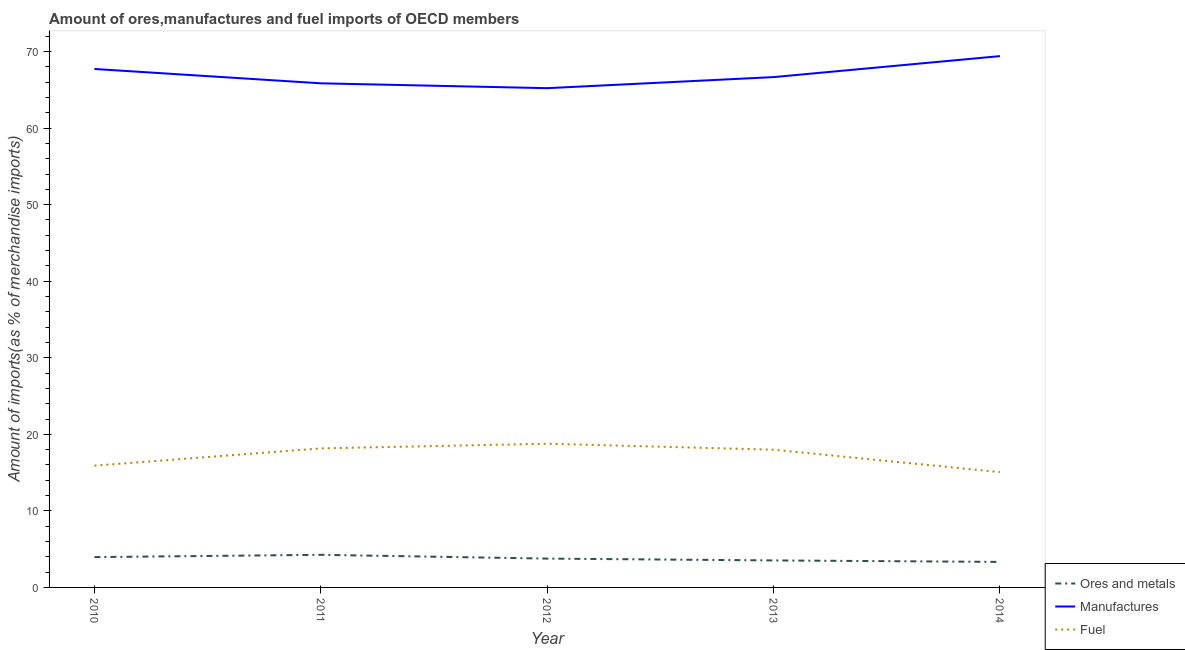How many different coloured lines are there?
Provide a short and direct response. 3. Is the number of lines equal to the number of legend labels?
Keep it short and to the point. Yes. What is the percentage of ores and metals imports in 2014?
Your answer should be compact. 3.33. Across all years, what is the maximum percentage of fuel imports?
Offer a very short reply. 18.77. Across all years, what is the minimum percentage of manufactures imports?
Your response must be concise. 65.22. In which year was the percentage of fuel imports minimum?
Ensure brevity in your answer.  2014. What is the total percentage of ores and metals imports in the graph?
Make the answer very short. 18.85. What is the difference between the percentage of manufactures imports in 2011 and that in 2013?
Ensure brevity in your answer.  -0.81. What is the difference between the percentage of fuel imports in 2013 and the percentage of manufactures imports in 2011?
Your answer should be very brief. -47.86. What is the average percentage of fuel imports per year?
Make the answer very short. 17.18. In the year 2013, what is the difference between the percentage of manufactures imports and percentage of ores and metals imports?
Your response must be concise. 63.14. What is the ratio of the percentage of ores and metals imports in 2010 to that in 2012?
Provide a short and direct response. 1.05. What is the difference between the highest and the second highest percentage of manufactures imports?
Provide a short and direct response. 1.68. What is the difference between the highest and the lowest percentage of ores and metals imports?
Ensure brevity in your answer.  0.93. Is it the case that in every year, the sum of the percentage of ores and metals imports and percentage of manufactures imports is greater than the percentage of fuel imports?
Provide a short and direct response. Yes. Is the percentage of fuel imports strictly less than the percentage of manufactures imports over the years?
Make the answer very short. Yes. How many lines are there?
Give a very brief answer. 3. Does the graph contain any zero values?
Provide a short and direct response. No. Does the graph contain grids?
Offer a terse response. No. Where does the legend appear in the graph?
Provide a short and direct response. Bottom right. How many legend labels are there?
Offer a terse response. 3. What is the title of the graph?
Give a very brief answer. Amount of ores,manufactures and fuel imports of OECD members. What is the label or title of the X-axis?
Keep it short and to the point. Year. What is the label or title of the Y-axis?
Your answer should be very brief. Amount of imports(as % of merchandise imports). What is the Amount of imports(as % of merchandise imports) in Ores and metals in 2010?
Offer a very short reply. 3.96. What is the Amount of imports(as % of merchandise imports) in Manufactures in 2010?
Provide a succinct answer. 67.73. What is the Amount of imports(as % of merchandise imports) in Fuel in 2010?
Keep it short and to the point. 15.91. What is the Amount of imports(as % of merchandise imports) in Ores and metals in 2011?
Keep it short and to the point. 4.26. What is the Amount of imports(as % of merchandise imports) in Manufactures in 2011?
Your answer should be compact. 65.85. What is the Amount of imports(as % of merchandise imports) in Fuel in 2011?
Your answer should be very brief. 18.16. What is the Amount of imports(as % of merchandise imports) in Ores and metals in 2012?
Provide a succinct answer. 3.77. What is the Amount of imports(as % of merchandise imports) of Manufactures in 2012?
Your response must be concise. 65.22. What is the Amount of imports(as % of merchandise imports) in Fuel in 2012?
Your answer should be compact. 18.77. What is the Amount of imports(as % of merchandise imports) of Ores and metals in 2013?
Your answer should be compact. 3.53. What is the Amount of imports(as % of merchandise imports) in Manufactures in 2013?
Offer a terse response. 66.66. What is the Amount of imports(as % of merchandise imports) in Fuel in 2013?
Give a very brief answer. 17.99. What is the Amount of imports(as % of merchandise imports) in Ores and metals in 2014?
Ensure brevity in your answer.  3.33. What is the Amount of imports(as % of merchandise imports) in Manufactures in 2014?
Provide a short and direct response. 69.41. What is the Amount of imports(as % of merchandise imports) in Fuel in 2014?
Your answer should be very brief. 15.06. Across all years, what is the maximum Amount of imports(as % of merchandise imports) of Ores and metals?
Provide a succinct answer. 4.26. Across all years, what is the maximum Amount of imports(as % of merchandise imports) in Manufactures?
Offer a very short reply. 69.41. Across all years, what is the maximum Amount of imports(as % of merchandise imports) in Fuel?
Keep it short and to the point. 18.77. Across all years, what is the minimum Amount of imports(as % of merchandise imports) in Ores and metals?
Ensure brevity in your answer.  3.33. Across all years, what is the minimum Amount of imports(as % of merchandise imports) of Manufactures?
Your answer should be compact. 65.22. Across all years, what is the minimum Amount of imports(as % of merchandise imports) of Fuel?
Give a very brief answer. 15.06. What is the total Amount of imports(as % of merchandise imports) in Ores and metals in the graph?
Offer a terse response. 18.85. What is the total Amount of imports(as % of merchandise imports) of Manufactures in the graph?
Your response must be concise. 334.87. What is the total Amount of imports(as % of merchandise imports) in Fuel in the graph?
Keep it short and to the point. 85.89. What is the difference between the Amount of imports(as % of merchandise imports) of Ores and metals in 2010 and that in 2011?
Provide a succinct answer. -0.3. What is the difference between the Amount of imports(as % of merchandise imports) in Manufactures in 2010 and that in 2011?
Make the answer very short. 1.87. What is the difference between the Amount of imports(as % of merchandise imports) in Fuel in 2010 and that in 2011?
Offer a very short reply. -2.25. What is the difference between the Amount of imports(as % of merchandise imports) of Ores and metals in 2010 and that in 2012?
Offer a very short reply. 0.19. What is the difference between the Amount of imports(as % of merchandise imports) in Manufactures in 2010 and that in 2012?
Provide a short and direct response. 2.51. What is the difference between the Amount of imports(as % of merchandise imports) of Fuel in 2010 and that in 2012?
Your answer should be compact. -2.87. What is the difference between the Amount of imports(as % of merchandise imports) in Ores and metals in 2010 and that in 2013?
Offer a terse response. 0.43. What is the difference between the Amount of imports(as % of merchandise imports) in Manufactures in 2010 and that in 2013?
Make the answer very short. 1.06. What is the difference between the Amount of imports(as % of merchandise imports) of Fuel in 2010 and that in 2013?
Offer a terse response. -2.08. What is the difference between the Amount of imports(as % of merchandise imports) of Ores and metals in 2010 and that in 2014?
Provide a short and direct response. 0.63. What is the difference between the Amount of imports(as % of merchandise imports) in Manufactures in 2010 and that in 2014?
Your response must be concise. -1.68. What is the difference between the Amount of imports(as % of merchandise imports) of Fuel in 2010 and that in 2014?
Ensure brevity in your answer.  0.85. What is the difference between the Amount of imports(as % of merchandise imports) in Ores and metals in 2011 and that in 2012?
Provide a succinct answer. 0.49. What is the difference between the Amount of imports(as % of merchandise imports) in Manufactures in 2011 and that in 2012?
Offer a very short reply. 0.64. What is the difference between the Amount of imports(as % of merchandise imports) of Fuel in 2011 and that in 2012?
Provide a succinct answer. -0.61. What is the difference between the Amount of imports(as % of merchandise imports) in Ores and metals in 2011 and that in 2013?
Offer a very short reply. 0.73. What is the difference between the Amount of imports(as % of merchandise imports) in Manufactures in 2011 and that in 2013?
Provide a succinct answer. -0.81. What is the difference between the Amount of imports(as % of merchandise imports) in Fuel in 2011 and that in 2013?
Your answer should be very brief. 0.17. What is the difference between the Amount of imports(as % of merchandise imports) of Ores and metals in 2011 and that in 2014?
Keep it short and to the point. 0.93. What is the difference between the Amount of imports(as % of merchandise imports) of Manufactures in 2011 and that in 2014?
Make the answer very short. -3.55. What is the difference between the Amount of imports(as % of merchandise imports) in Fuel in 2011 and that in 2014?
Provide a succinct answer. 3.1. What is the difference between the Amount of imports(as % of merchandise imports) of Ores and metals in 2012 and that in 2013?
Provide a short and direct response. 0.24. What is the difference between the Amount of imports(as % of merchandise imports) in Manufactures in 2012 and that in 2013?
Make the answer very short. -1.45. What is the difference between the Amount of imports(as % of merchandise imports) in Fuel in 2012 and that in 2013?
Keep it short and to the point. 0.78. What is the difference between the Amount of imports(as % of merchandise imports) of Ores and metals in 2012 and that in 2014?
Offer a very short reply. 0.43. What is the difference between the Amount of imports(as % of merchandise imports) in Manufactures in 2012 and that in 2014?
Provide a succinct answer. -4.19. What is the difference between the Amount of imports(as % of merchandise imports) in Fuel in 2012 and that in 2014?
Give a very brief answer. 3.71. What is the difference between the Amount of imports(as % of merchandise imports) of Ores and metals in 2013 and that in 2014?
Provide a succinct answer. 0.19. What is the difference between the Amount of imports(as % of merchandise imports) of Manufactures in 2013 and that in 2014?
Provide a succinct answer. -2.74. What is the difference between the Amount of imports(as % of merchandise imports) in Fuel in 2013 and that in 2014?
Your answer should be compact. 2.93. What is the difference between the Amount of imports(as % of merchandise imports) in Ores and metals in 2010 and the Amount of imports(as % of merchandise imports) in Manufactures in 2011?
Keep it short and to the point. -61.89. What is the difference between the Amount of imports(as % of merchandise imports) in Ores and metals in 2010 and the Amount of imports(as % of merchandise imports) in Fuel in 2011?
Your answer should be very brief. -14.2. What is the difference between the Amount of imports(as % of merchandise imports) in Manufactures in 2010 and the Amount of imports(as % of merchandise imports) in Fuel in 2011?
Offer a very short reply. 49.56. What is the difference between the Amount of imports(as % of merchandise imports) of Ores and metals in 2010 and the Amount of imports(as % of merchandise imports) of Manufactures in 2012?
Your answer should be very brief. -61.26. What is the difference between the Amount of imports(as % of merchandise imports) in Ores and metals in 2010 and the Amount of imports(as % of merchandise imports) in Fuel in 2012?
Ensure brevity in your answer.  -14.81. What is the difference between the Amount of imports(as % of merchandise imports) in Manufactures in 2010 and the Amount of imports(as % of merchandise imports) in Fuel in 2012?
Your response must be concise. 48.95. What is the difference between the Amount of imports(as % of merchandise imports) of Ores and metals in 2010 and the Amount of imports(as % of merchandise imports) of Manufactures in 2013?
Keep it short and to the point. -62.7. What is the difference between the Amount of imports(as % of merchandise imports) in Ores and metals in 2010 and the Amount of imports(as % of merchandise imports) in Fuel in 2013?
Give a very brief answer. -14.03. What is the difference between the Amount of imports(as % of merchandise imports) of Manufactures in 2010 and the Amount of imports(as % of merchandise imports) of Fuel in 2013?
Provide a succinct answer. 49.74. What is the difference between the Amount of imports(as % of merchandise imports) of Ores and metals in 2010 and the Amount of imports(as % of merchandise imports) of Manufactures in 2014?
Offer a very short reply. -65.44. What is the difference between the Amount of imports(as % of merchandise imports) in Ores and metals in 2010 and the Amount of imports(as % of merchandise imports) in Fuel in 2014?
Offer a very short reply. -11.1. What is the difference between the Amount of imports(as % of merchandise imports) in Manufactures in 2010 and the Amount of imports(as % of merchandise imports) in Fuel in 2014?
Make the answer very short. 52.67. What is the difference between the Amount of imports(as % of merchandise imports) in Ores and metals in 2011 and the Amount of imports(as % of merchandise imports) in Manufactures in 2012?
Ensure brevity in your answer.  -60.96. What is the difference between the Amount of imports(as % of merchandise imports) of Ores and metals in 2011 and the Amount of imports(as % of merchandise imports) of Fuel in 2012?
Make the answer very short. -14.51. What is the difference between the Amount of imports(as % of merchandise imports) of Manufactures in 2011 and the Amount of imports(as % of merchandise imports) of Fuel in 2012?
Offer a very short reply. 47.08. What is the difference between the Amount of imports(as % of merchandise imports) in Ores and metals in 2011 and the Amount of imports(as % of merchandise imports) in Manufactures in 2013?
Provide a short and direct response. -62.4. What is the difference between the Amount of imports(as % of merchandise imports) in Ores and metals in 2011 and the Amount of imports(as % of merchandise imports) in Fuel in 2013?
Offer a terse response. -13.73. What is the difference between the Amount of imports(as % of merchandise imports) of Manufactures in 2011 and the Amount of imports(as % of merchandise imports) of Fuel in 2013?
Give a very brief answer. 47.86. What is the difference between the Amount of imports(as % of merchandise imports) in Ores and metals in 2011 and the Amount of imports(as % of merchandise imports) in Manufactures in 2014?
Provide a short and direct response. -65.15. What is the difference between the Amount of imports(as % of merchandise imports) in Ores and metals in 2011 and the Amount of imports(as % of merchandise imports) in Fuel in 2014?
Make the answer very short. -10.8. What is the difference between the Amount of imports(as % of merchandise imports) of Manufactures in 2011 and the Amount of imports(as % of merchandise imports) of Fuel in 2014?
Your response must be concise. 50.79. What is the difference between the Amount of imports(as % of merchandise imports) in Ores and metals in 2012 and the Amount of imports(as % of merchandise imports) in Manufactures in 2013?
Keep it short and to the point. -62.9. What is the difference between the Amount of imports(as % of merchandise imports) in Ores and metals in 2012 and the Amount of imports(as % of merchandise imports) in Fuel in 2013?
Keep it short and to the point. -14.22. What is the difference between the Amount of imports(as % of merchandise imports) of Manufactures in 2012 and the Amount of imports(as % of merchandise imports) of Fuel in 2013?
Provide a succinct answer. 47.23. What is the difference between the Amount of imports(as % of merchandise imports) of Ores and metals in 2012 and the Amount of imports(as % of merchandise imports) of Manufactures in 2014?
Your answer should be compact. -65.64. What is the difference between the Amount of imports(as % of merchandise imports) in Ores and metals in 2012 and the Amount of imports(as % of merchandise imports) in Fuel in 2014?
Keep it short and to the point. -11.29. What is the difference between the Amount of imports(as % of merchandise imports) in Manufactures in 2012 and the Amount of imports(as % of merchandise imports) in Fuel in 2014?
Make the answer very short. 50.16. What is the difference between the Amount of imports(as % of merchandise imports) in Ores and metals in 2013 and the Amount of imports(as % of merchandise imports) in Manufactures in 2014?
Your answer should be very brief. -65.88. What is the difference between the Amount of imports(as % of merchandise imports) of Ores and metals in 2013 and the Amount of imports(as % of merchandise imports) of Fuel in 2014?
Make the answer very short. -11.53. What is the difference between the Amount of imports(as % of merchandise imports) of Manufactures in 2013 and the Amount of imports(as % of merchandise imports) of Fuel in 2014?
Keep it short and to the point. 51.6. What is the average Amount of imports(as % of merchandise imports) in Ores and metals per year?
Your answer should be very brief. 3.77. What is the average Amount of imports(as % of merchandise imports) in Manufactures per year?
Make the answer very short. 66.97. What is the average Amount of imports(as % of merchandise imports) in Fuel per year?
Give a very brief answer. 17.18. In the year 2010, what is the difference between the Amount of imports(as % of merchandise imports) of Ores and metals and Amount of imports(as % of merchandise imports) of Manufactures?
Offer a very short reply. -63.77. In the year 2010, what is the difference between the Amount of imports(as % of merchandise imports) in Ores and metals and Amount of imports(as % of merchandise imports) in Fuel?
Your response must be concise. -11.95. In the year 2010, what is the difference between the Amount of imports(as % of merchandise imports) of Manufactures and Amount of imports(as % of merchandise imports) of Fuel?
Provide a short and direct response. 51.82. In the year 2011, what is the difference between the Amount of imports(as % of merchandise imports) of Ores and metals and Amount of imports(as % of merchandise imports) of Manufactures?
Your response must be concise. -61.59. In the year 2011, what is the difference between the Amount of imports(as % of merchandise imports) of Ores and metals and Amount of imports(as % of merchandise imports) of Fuel?
Your response must be concise. -13.9. In the year 2011, what is the difference between the Amount of imports(as % of merchandise imports) of Manufactures and Amount of imports(as % of merchandise imports) of Fuel?
Make the answer very short. 47.69. In the year 2012, what is the difference between the Amount of imports(as % of merchandise imports) in Ores and metals and Amount of imports(as % of merchandise imports) in Manufactures?
Make the answer very short. -61.45. In the year 2012, what is the difference between the Amount of imports(as % of merchandise imports) in Ores and metals and Amount of imports(as % of merchandise imports) in Fuel?
Your response must be concise. -15.01. In the year 2012, what is the difference between the Amount of imports(as % of merchandise imports) of Manufactures and Amount of imports(as % of merchandise imports) of Fuel?
Provide a succinct answer. 46.45. In the year 2013, what is the difference between the Amount of imports(as % of merchandise imports) in Ores and metals and Amount of imports(as % of merchandise imports) in Manufactures?
Provide a succinct answer. -63.14. In the year 2013, what is the difference between the Amount of imports(as % of merchandise imports) in Ores and metals and Amount of imports(as % of merchandise imports) in Fuel?
Your response must be concise. -14.46. In the year 2013, what is the difference between the Amount of imports(as % of merchandise imports) of Manufactures and Amount of imports(as % of merchandise imports) of Fuel?
Keep it short and to the point. 48.67. In the year 2014, what is the difference between the Amount of imports(as % of merchandise imports) in Ores and metals and Amount of imports(as % of merchandise imports) in Manufactures?
Keep it short and to the point. -66.07. In the year 2014, what is the difference between the Amount of imports(as % of merchandise imports) of Ores and metals and Amount of imports(as % of merchandise imports) of Fuel?
Keep it short and to the point. -11.73. In the year 2014, what is the difference between the Amount of imports(as % of merchandise imports) of Manufactures and Amount of imports(as % of merchandise imports) of Fuel?
Offer a very short reply. 54.34. What is the ratio of the Amount of imports(as % of merchandise imports) in Ores and metals in 2010 to that in 2011?
Your answer should be compact. 0.93. What is the ratio of the Amount of imports(as % of merchandise imports) in Manufactures in 2010 to that in 2011?
Offer a very short reply. 1.03. What is the ratio of the Amount of imports(as % of merchandise imports) of Fuel in 2010 to that in 2011?
Your answer should be compact. 0.88. What is the ratio of the Amount of imports(as % of merchandise imports) in Ores and metals in 2010 to that in 2012?
Offer a terse response. 1.05. What is the ratio of the Amount of imports(as % of merchandise imports) of Fuel in 2010 to that in 2012?
Offer a terse response. 0.85. What is the ratio of the Amount of imports(as % of merchandise imports) of Ores and metals in 2010 to that in 2013?
Offer a terse response. 1.12. What is the ratio of the Amount of imports(as % of merchandise imports) of Manufactures in 2010 to that in 2013?
Ensure brevity in your answer.  1.02. What is the ratio of the Amount of imports(as % of merchandise imports) in Fuel in 2010 to that in 2013?
Offer a very short reply. 0.88. What is the ratio of the Amount of imports(as % of merchandise imports) in Ores and metals in 2010 to that in 2014?
Your answer should be very brief. 1.19. What is the ratio of the Amount of imports(as % of merchandise imports) of Manufactures in 2010 to that in 2014?
Provide a short and direct response. 0.98. What is the ratio of the Amount of imports(as % of merchandise imports) in Fuel in 2010 to that in 2014?
Provide a succinct answer. 1.06. What is the ratio of the Amount of imports(as % of merchandise imports) of Ores and metals in 2011 to that in 2012?
Your response must be concise. 1.13. What is the ratio of the Amount of imports(as % of merchandise imports) of Manufactures in 2011 to that in 2012?
Make the answer very short. 1.01. What is the ratio of the Amount of imports(as % of merchandise imports) in Fuel in 2011 to that in 2012?
Offer a very short reply. 0.97. What is the ratio of the Amount of imports(as % of merchandise imports) of Ores and metals in 2011 to that in 2013?
Provide a succinct answer. 1.21. What is the ratio of the Amount of imports(as % of merchandise imports) in Fuel in 2011 to that in 2013?
Give a very brief answer. 1.01. What is the ratio of the Amount of imports(as % of merchandise imports) of Ores and metals in 2011 to that in 2014?
Ensure brevity in your answer.  1.28. What is the ratio of the Amount of imports(as % of merchandise imports) in Manufactures in 2011 to that in 2014?
Make the answer very short. 0.95. What is the ratio of the Amount of imports(as % of merchandise imports) in Fuel in 2011 to that in 2014?
Keep it short and to the point. 1.21. What is the ratio of the Amount of imports(as % of merchandise imports) of Ores and metals in 2012 to that in 2013?
Give a very brief answer. 1.07. What is the ratio of the Amount of imports(as % of merchandise imports) in Manufactures in 2012 to that in 2013?
Keep it short and to the point. 0.98. What is the ratio of the Amount of imports(as % of merchandise imports) of Fuel in 2012 to that in 2013?
Offer a terse response. 1.04. What is the ratio of the Amount of imports(as % of merchandise imports) of Ores and metals in 2012 to that in 2014?
Your answer should be compact. 1.13. What is the ratio of the Amount of imports(as % of merchandise imports) of Manufactures in 2012 to that in 2014?
Keep it short and to the point. 0.94. What is the ratio of the Amount of imports(as % of merchandise imports) in Fuel in 2012 to that in 2014?
Provide a succinct answer. 1.25. What is the ratio of the Amount of imports(as % of merchandise imports) of Ores and metals in 2013 to that in 2014?
Offer a very short reply. 1.06. What is the ratio of the Amount of imports(as % of merchandise imports) in Manufactures in 2013 to that in 2014?
Your answer should be very brief. 0.96. What is the ratio of the Amount of imports(as % of merchandise imports) of Fuel in 2013 to that in 2014?
Make the answer very short. 1.19. What is the difference between the highest and the second highest Amount of imports(as % of merchandise imports) of Ores and metals?
Your answer should be compact. 0.3. What is the difference between the highest and the second highest Amount of imports(as % of merchandise imports) of Manufactures?
Keep it short and to the point. 1.68. What is the difference between the highest and the second highest Amount of imports(as % of merchandise imports) of Fuel?
Provide a short and direct response. 0.61. What is the difference between the highest and the lowest Amount of imports(as % of merchandise imports) of Ores and metals?
Make the answer very short. 0.93. What is the difference between the highest and the lowest Amount of imports(as % of merchandise imports) of Manufactures?
Provide a short and direct response. 4.19. What is the difference between the highest and the lowest Amount of imports(as % of merchandise imports) of Fuel?
Keep it short and to the point. 3.71. 